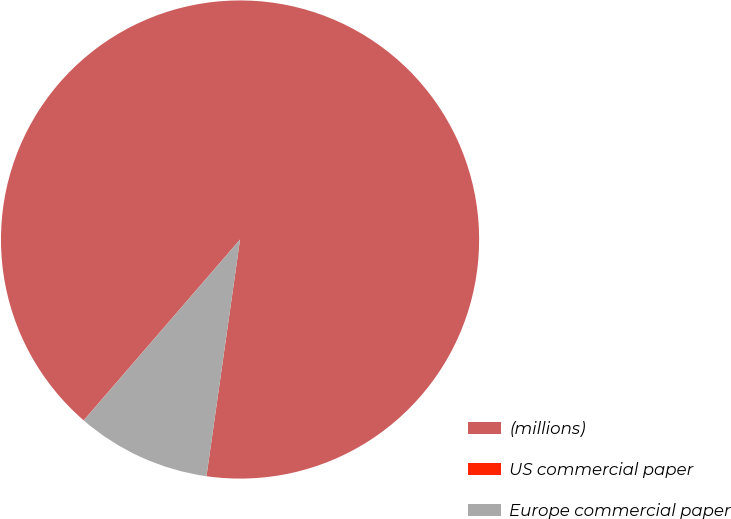Convert chart to OTSL. <chart><loc_0><loc_0><loc_500><loc_500><pie_chart><fcel>(millions)<fcel>US commercial paper<fcel>Europe commercial paper<nl><fcel>90.89%<fcel>0.01%<fcel>9.1%<nl></chart> 